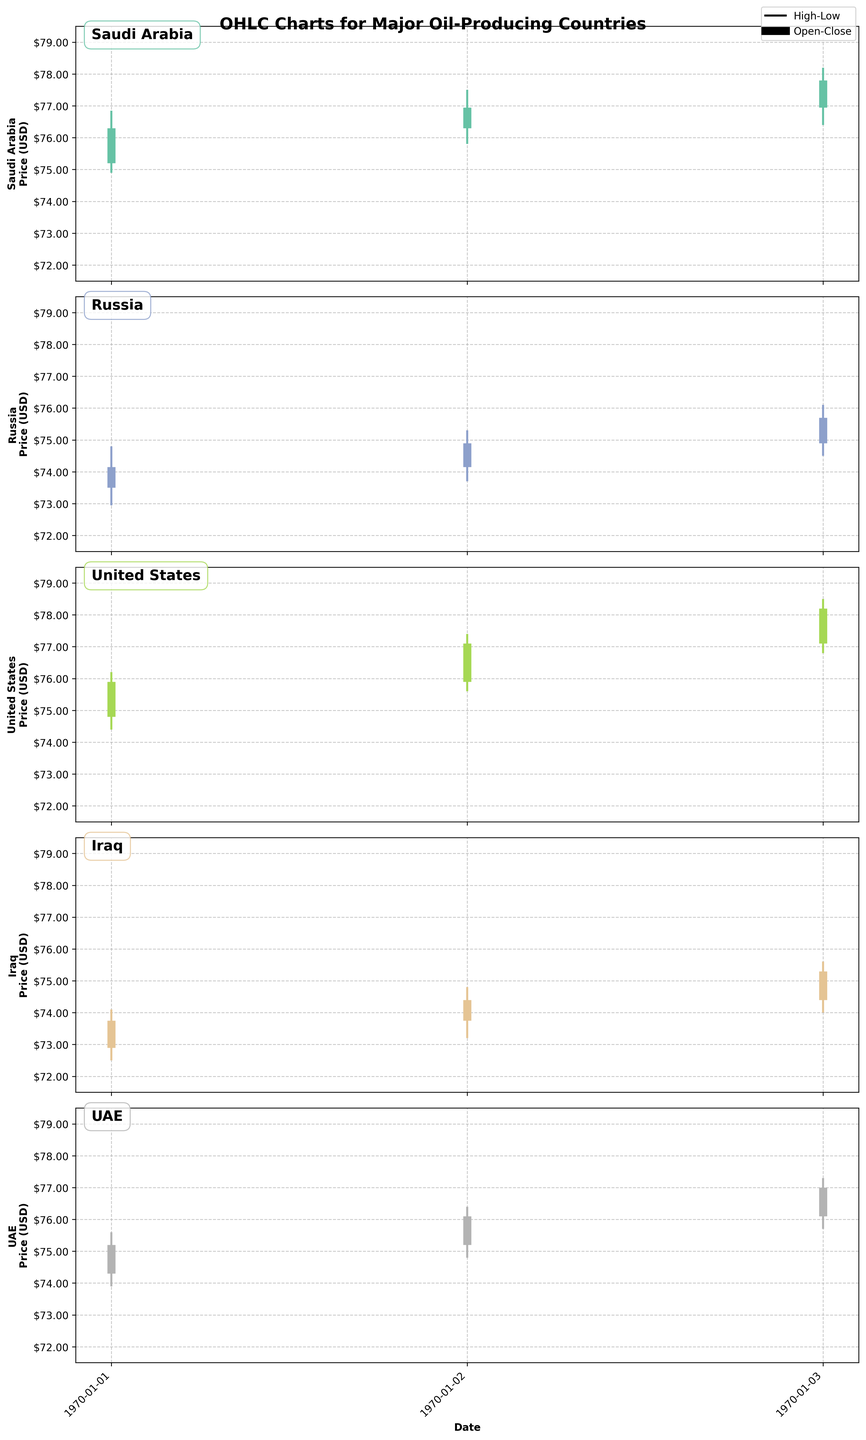What is the title of the figure? The title of the figure is located at the top and states the main focus of the visualization. It helps the observer understand the overall theme. In this case, it reads "OHLC Charts for Major Oil-Producing Countries".
Answer: OHLC Charts for Major Oil-Producing Countries Which country has the highest closing price on May 3, 2023? By examining the closing prices for each country on May 3, 2023, we see that the United States has the highest closing price, marked as 78.20.
Answer: United States How many countries are shown in the figure? Count the number of unique countries represented in the OHLC charts from the data. We have Saudi Arabia, Russia, United States, Iraq, and UAE. So, there are 5 countries.
Answer: 5 Which country had the biggest difference between the high and low prices on May 2, 2023? Calculate the difference between high and low prices for each country on May 2, 2023. The differences are: Saudi Arabia (1.70), Russia (1.60), United States (1.80), Iraq (1.60), and UAE (1.60). The United States has the biggest difference.
Answer: United States Across the three days shown, which country's prices show a continuous increase in the closing price each day? Examine the closing prices day-by-day for each country and check for continuous increase. For Saudi Arabia: 76.30, 76.95, 77.80; all values are increasing. Other countries do not have a continuous increase.
Answer: Saudi Arabia What is the lowest opening price recorded across all countries and dates? Review all the opening prices and find the minimum value. The lowest opening price recorded is 72.90 by Iraq on May 1, 2023.
Answer: 72.90 Which country shows the smallest fluctuation between open and close prices on May 1, 2023? Determine the absolute difference between the open and close prices on May 1, 2023 for each country. The differences are: Saudi Arabia (1.10), Russia (0.65), United States (1.10), Iraq (0.85), UAE (0.90). Russia shows the smallest fluctuation.
Answer: Russia What is the average closing price for UAE over the three days? Calculate the sum of the closing prices for UAE over the three dates and divide by 3. The sum is 75.20 + 76.10 + 77.00 = 228.30, so the average is 228.30 / 3.
Answer: 76.10 Which country had an increase in price from opening to closing on all three days? Check the opening and closing prices for each day. For Saudi Arabia: 75.20 to 76.30, 76.30 to 76.95, 76.95 to 77.80; all three days show an increase.
Answer: Saudi Arabia 